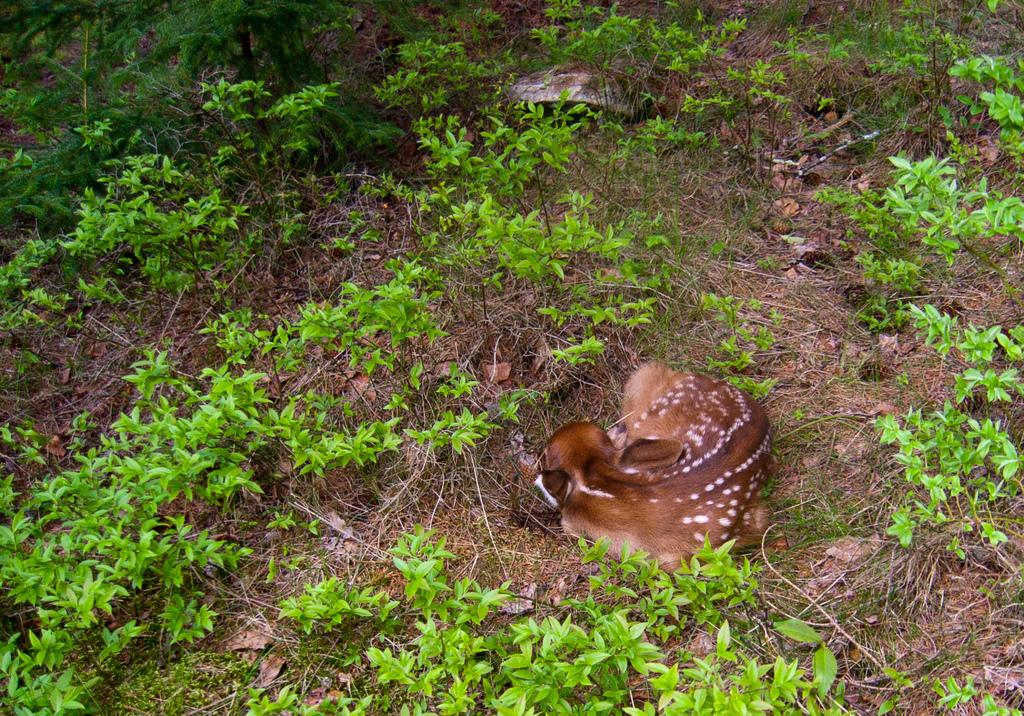What type of animal is in the image? There is a deer in the image. Where is the deer located in the image? The deer is on the ground in the image. What type of vegetation is present in the image? There are plants in the image. Can you see a stream in the image? There is no stream present in the image. What type of dress is the deer wearing in the image? The deer is a wild animal and does not wear clothing, so it is not wearing a dress in the image. 